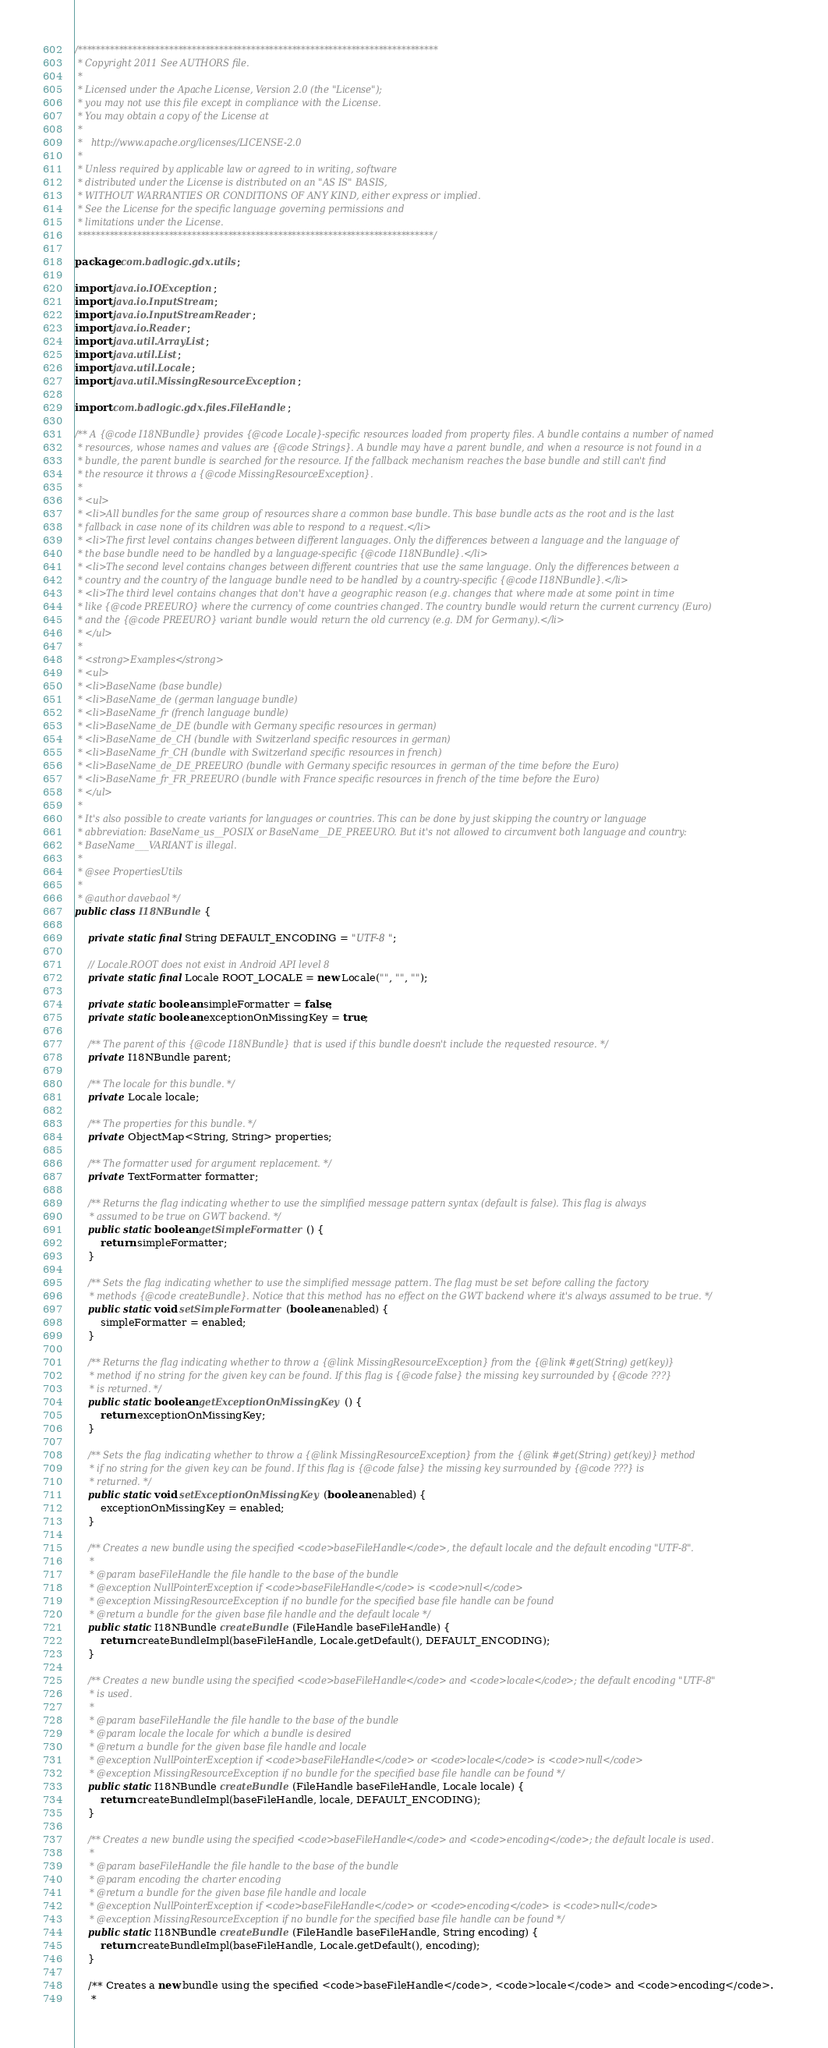Convert code to text. <code><loc_0><loc_0><loc_500><loc_500><_Java_>/*******************************************************************************
 * Copyright 2011 See AUTHORS file.
 * 
 * Licensed under the Apache License, Version 2.0 (the "License");
 * you may not use this file except in compliance with the License.
 * You may obtain a copy of the License at
 * 
 *   http://www.apache.org/licenses/LICENSE-2.0
 * 
 * Unless required by applicable law or agreed to in writing, software
 * distributed under the License is distributed on an "AS IS" BASIS,
 * WITHOUT WARRANTIES OR CONDITIONS OF ANY KIND, either express or implied.
 * See the License for the specific language governing permissions and
 * limitations under the License.
 ******************************************************************************/

package com.badlogic.gdx.utils;

import java.io.IOException;
import java.io.InputStream;
import java.io.InputStreamReader;
import java.io.Reader;
import java.util.ArrayList;
import java.util.List;
import java.util.Locale;
import java.util.MissingResourceException;

import com.badlogic.gdx.files.FileHandle;

/** A {@code I18NBundle} provides {@code Locale}-specific resources loaded from property files. A bundle contains a number of named
 * resources, whose names and values are {@code Strings}. A bundle may have a parent bundle, and when a resource is not found in a
 * bundle, the parent bundle is searched for the resource. If the fallback mechanism reaches the base bundle and still can't find
 * the resource it throws a {@code MissingResourceException}.
 * 
 * <ul>
 * <li>All bundles for the same group of resources share a common base bundle. This base bundle acts as the root and is the last
 * fallback in case none of its children was able to respond to a request.</li>
 * <li>The first level contains changes between different languages. Only the differences between a language and the language of
 * the base bundle need to be handled by a language-specific {@code I18NBundle}.</li>
 * <li>The second level contains changes between different countries that use the same language. Only the differences between a
 * country and the country of the language bundle need to be handled by a country-specific {@code I18NBundle}.</li>
 * <li>The third level contains changes that don't have a geographic reason (e.g. changes that where made at some point in time
 * like {@code PREEURO} where the currency of come countries changed. The country bundle would return the current currency (Euro)
 * and the {@code PREEURO} variant bundle would return the old currency (e.g. DM for Germany).</li>
 * </ul>
 * 
 * <strong>Examples</strong>
 * <ul>
 * <li>BaseName (base bundle)
 * <li>BaseName_de (german language bundle)
 * <li>BaseName_fr (french language bundle)
 * <li>BaseName_de_DE (bundle with Germany specific resources in german)
 * <li>BaseName_de_CH (bundle with Switzerland specific resources in german)
 * <li>BaseName_fr_CH (bundle with Switzerland specific resources in french)
 * <li>BaseName_de_DE_PREEURO (bundle with Germany specific resources in german of the time before the Euro)
 * <li>BaseName_fr_FR_PREEURO (bundle with France specific resources in french of the time before the Euro)
 * </ul>
 * 
 * It's also possible to create variants for languages or countries. This can be done by just skipping the country or language
 * abbreviation: BaseName_us__POSIX or BaseName__DE_PREEURO. But it's not allowed to circumvent both language and country:
 * BaseName___VARIANT is illegal.
 * 
 * @see PropertiesUtils
 * 
 * @author davebaol */
public class I18NBundle {

	private static final String DEFAULT_ENCODING = "UTF-8";

	// Locale.ROOT does not exist in Android API level 8
	private static final Locale ROOT_LOCALE = new Locale("", "", "");

	private static boolean simpleFormatter = false;
	private static boolean exceptionOnMissingKey = true;

	/** The parent of this {@code I18NBundle} that is used if this bundle doesn't include the requested resource. */
	private I18NBundle parent;

	/** The locale for this bundle. */
	private Locale locale;

	/** The properties for this bundle. */
	private ObjectMap<String, String> properties;

	/** The formatter used for argument replacement. */
	private TextFormatter formatter;

	/** Returns the flag indicating whether to use the simplified message pattern syntax (default is false). This flag is always
	 * assumed to be true on GWT backend. */
	public static boolean getSimpleFormatter () {
		return simpleFormatter;
	}

	/** Sets the flag indicating whether to use the simplified message pattern. The flag must be set before calling the factory
	 * methods {@code createBundle}. Notice that this method has no effect on the GWT backend where it's always assumed to be true. */
	public static void setSimpleFormatter (boolean enabled) {
		simpleFormatter = enabled;
	}

	/** Returns the flag indicating whether to throw a {@link MissingResourceException} from the {@link #get(String) get(key)}
	 * method if no string for the given key can be found. If this flag is {@code false} the missing key surrounded by {@code ???}
	 * is returned. */
	public static boolean getExceptionOnMissingKey () {
		return exceptionOnMissingKey;
	}

	/** Sets the flag indicating whether to throw a {@link MissingResourceException} from the {@link #get(String) get(key)} method
	 * if no string for the given key can be found. If this flag is {@code false} the missing key surrounded by {@code ???} is
	 * returned. */
	public static void setExceptionOnMissingKey (boolean enabled) {
		exceptionOnMissingKey = enabled;
	}

	/** Creates a new bundle using the specified <code>baseFileHandle</code>, the default locale and the default encoding "UTF-8".
	 * 
	 * @param baseFileHandle the file handle to the base of the bundle
	 * @exception NullPointerException if <code>baseFileHandle</code> is <code>null</code>
	 * @exception MissingResourceException if no bundle for the specified base file handle can be found
	 * @return a bundle for the given base file handle and the default locale */
	public static I18NBundle createBundle (FileHandle baseFileHandle) {
		return createBundleImpl(baseFileHandle, Locale.getDefault(), DEFAULT_ENCODING);
	}

	/** Creates a new bundle using the specified <code>baseFileHandle</code> and <code>locale</code>; the default encoding "UTF-8"
	 * is used.
	 * 
	 * @param baseFileHandle the file handle to the base of the bundle
	 * @param locale the locale for which a bundle is desired
	 * @return a bundle for the given base file handle and locale
	 * @exception NullPointerException if <code>baseFileHandle</code> or <code>locale</code> is <code>null</code>
	 * @exception MissingResourceException if no bundle for the specified base file handle can be found */
	public static I18NBundle createBundle (FileHandle baseFileHandle, Locale locale) {
		return createBundleImpl(baseFileHandle, locale, DEFAULT_ENCODING);
	}

	/** Creates a new bundle using the specified <code>baseFileHandle</code> and <code>encoding</code>; the default locale is used.
	 * 
	 * @param baseFileHandle the file handle to the base of the bundle
	 * @param encoding the charter encoding
	 * @return a bundle for the given base file handle and locale
	 * @exception NullPointerException if <code>baseFileHandle</code> or <code>encoding</code> is <code>null</code>
	 * @exception MissingResourceException if no bundle for the specified base file handle can be found */
	public static I18NBundle createBundle (FileHandle baseFileHandle, String encoding) {
		return createBundleImpl(baseFileHandle, Locale.getDefault(), encoding);
	}

	/** Creates a new bundle using the specified <code>baseFileHandle</code>, <code>locale</code> and <code>encoding</code>.
	 * </code> 